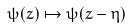<formula> <loc_0><loc_0><loc_500><loc_500>\psi ( z ) \mapsto \psi ( z - \eta )</formula> 